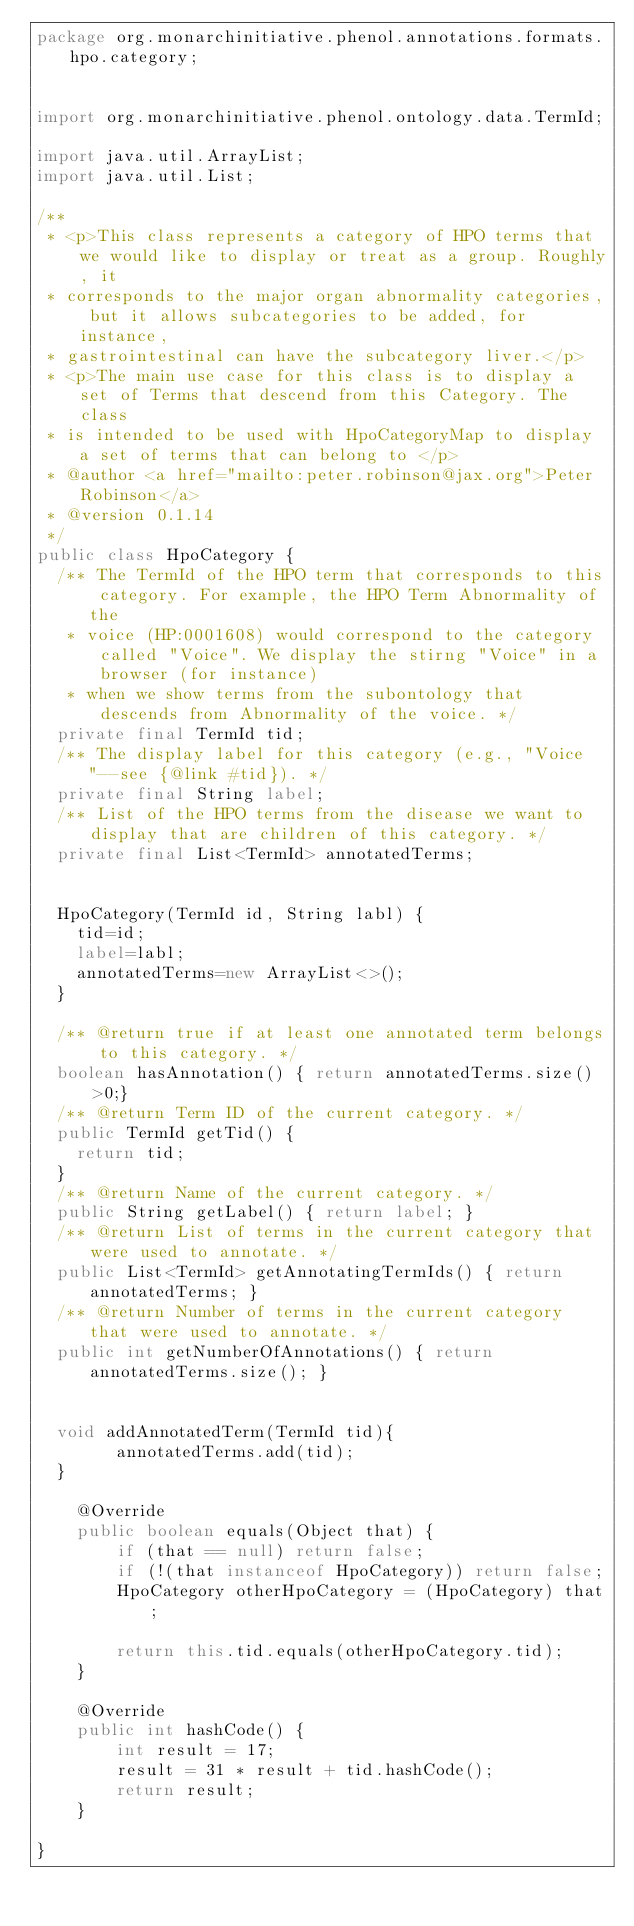<code> <loc_0><loc_0><loc_500><loc_500><_Java_>package org.monarchinitiative.phenol.annotations.formats.hpo.category;


import org.monarchinitiative.phenol.ontology.data.TermId;

import java.util.ArrayList;
import java.util.List;

/**
 * <p>This class represents a category of HPO terms that we would like to display or treat as a group. Roughly, it
 * corresponds to the major organ abnormality categories, but it allows subcategories to be added, for instance,
 * gastrointestinal can have the subcategory liver.</p>
 * <p>The main use case for this class is to display a set of Terms that descend from this Category. The class
 * is intended to be used with HpoCategoryMap to display a set of terms that can belong to </p>
 * @author <a href="mailto:peter.robinson@jax.org">Peter Robinson</a>
 * @version 0.1.14
 */
public class HpoCategory {
  /** The TermId of the HPO term that corresponds to this category. For example, the HPO Term Abnormality of the
   * voice (HP:0001608) would correspond to the category called "Voice". We display the stirng "Voice" in a browser (for instance)
   * when we show terms from the subontology that descends from Abnormality of the voice. */
  private final TermId tid;
  /** The display label for this category (e.g., "Voice"--see {@link #tid}). */
  private final String label;
  /** List of the HPO terms from the disease we want to display that are children of this category. */
  private final List<TermId> annotatedTerms;


  HpoCategory(TermId id, String labl) {
    tid=id;
    label=labl;
    annotatedTerms=new ArrayList<>();
  }

  /** @return true if at least one annotated term belongs to this category. */
  boolean hasAnnotation() { return annotatedTerms.size()>0;}
  /** @return Term ID of the current category. */
  public TermId getTid() {
    return tid;
  }
  /** @return Name of the current category. */
  public String getLabel() { return label; }
  /** @return List of terms in the current category that were used to annotate. */
  public List<TermId> getAnnotatingTermIds() { return annotatedTerms; }
  /** @return Number of terms in the current category that were used to annotate. */
  public int getNumberOfAnnotations() { return annotatedTerms.size(); }


  void addAnnotatedTerm(TermId tid){
        annotatedTerms.add(tid);
  }

    @Override
    public boolean equals(Object that) {
        if (that == null) return false;
        if (!(that instanceof HpoCategory)) return false;
        HpoCategory otherHpoCategory = (HpoCategory) that;

        return this.tid.equals(otherHpoCategory.tid);
    }

    @Override
    public int hashCode() {
        int result = 17;
        result = 31 * result + tid.hashCode();
        return result;
    }

}
</code> 